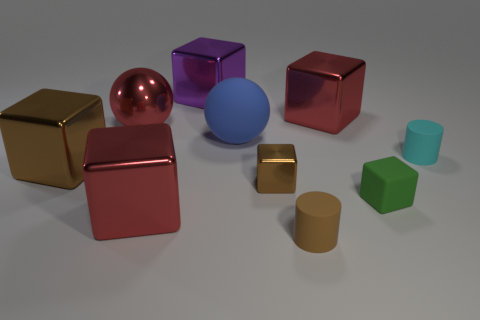Subtract all tiny green matte blocks. How many blocks are left? 5 Subtract all spheres. How many objects are left? 8 Subtract all blue balls. How many balls are left? 1 Subtract all cyan blocks. How many brown cylinders are left? 1 Subtract 1 purple cubes. How many objects are left? 9 Subtract 1 cubes. How many cubes are left? 5 Subtract all green balls. Subtract all green blocks. How many balls are left? 2 Subtract all cyan metallic spheres. Subtract all tiny green rubber things. How many objects are left? 9 Add 7 purple objects. How many purple objects are left? 8 Add 5 big brown shiny cubes. How many big brown shiny cubes exist? 6 